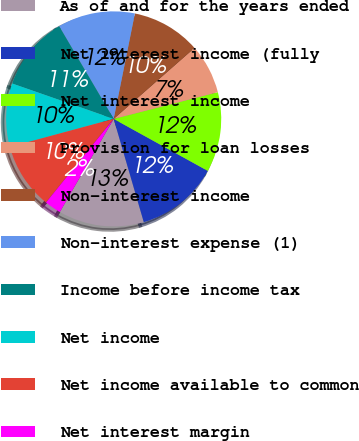Convert chart to OTSL. <chart><loc_0><loc_0><loc_500><loc_500><pie_chart><fcel>As of and for the years ended<fcel>Net interest income (fully<fcel>Net interest income<fcel>Provision for loan losses<fcel>Non-interest income<fcel>Non-interest expense (1)<fcel>Income before income tax<fcel>Net income<fcel>Net income available to common<fcel>Net interest margin<nl><fcel>12.86%<fcel>12.45%<fcel>12.03%<fcel>7.47%<fcel>10.37%<fcel>11.62%<fcel>11.2%<fcel>9.54%<fcel>9.96%<fcel>2.49%<nl></chart> 